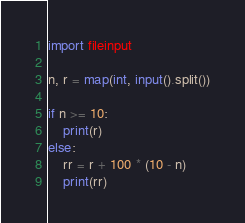<code> <loc_0><loc_0><loc_500><loc_500><_Python_>import fileinput

n, r = map(int, input().split())

if n >= 10:
    print(r)
else:
    rr = r + 100 * (10 - n)
    print(rr)

</code> 